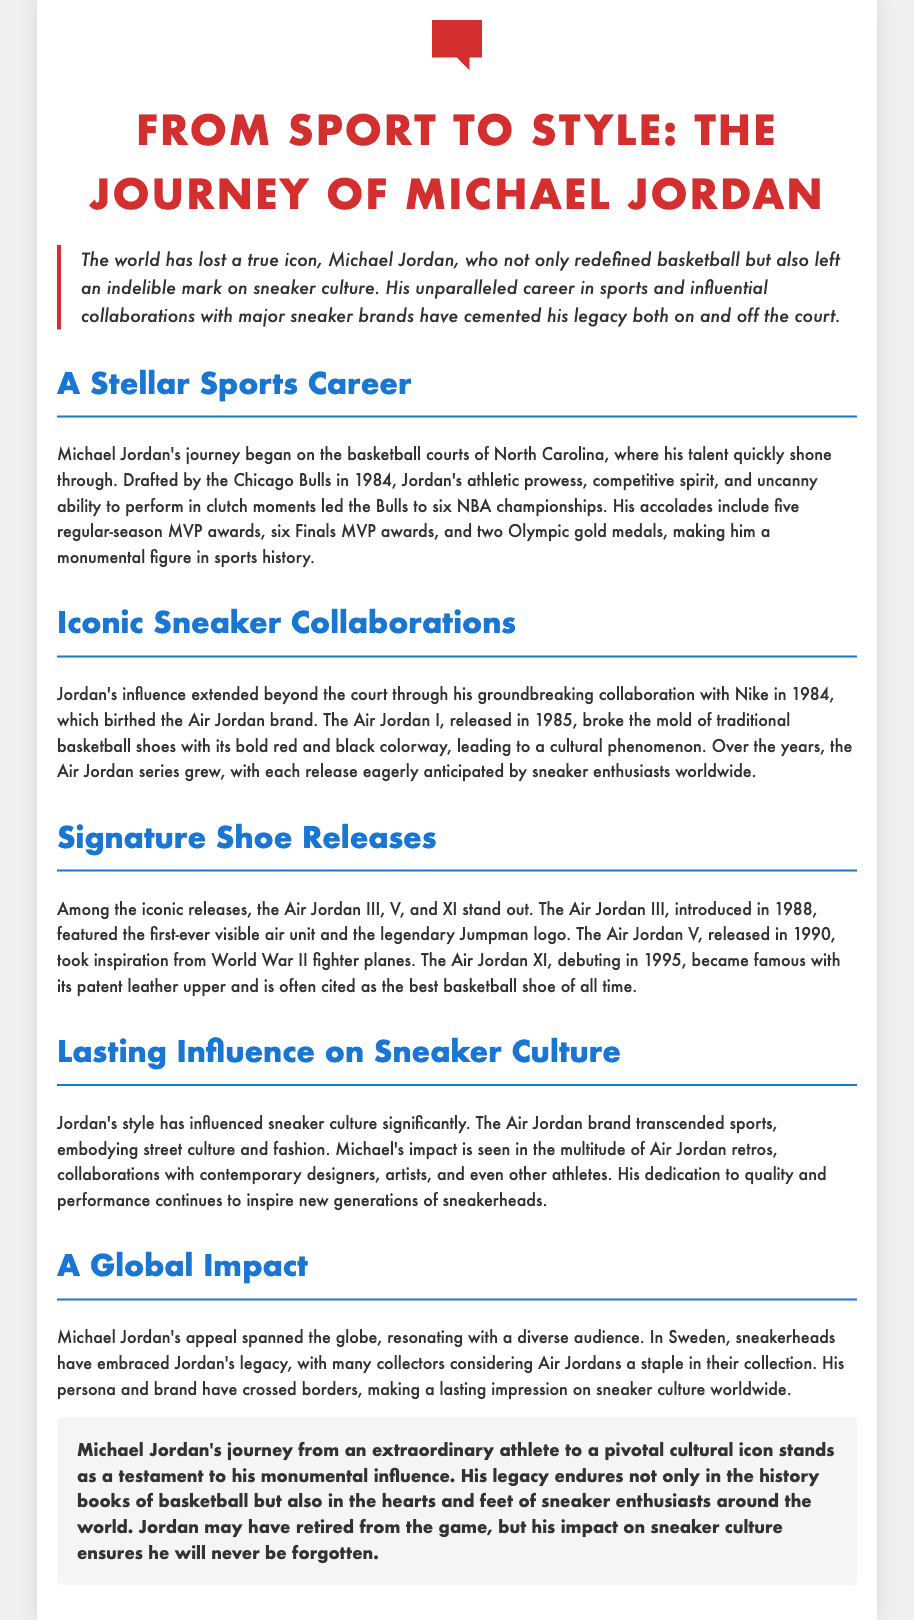What year was Michael Jordan drafted? Michael Jordan was drafted by the Chicago Bulls in 1984, which is mentioned in the document.
Answer: 1984 What is the name of the iconic shoe released in 1985? The Air Jordan I, released in 1985, is highlighted in the document as a groundbreaking shoe.
Answer: Air Jordan I How many NBA championships did Michael Jordan win? The document states that Jordan led the Bulls to six NBA championships.
Answer: Six What was the first Air Jordan model to feature a visible air unit? The Air Jordan III, introduced in 1988, featured the first-ever visible air unit according to the document.
Answer: Air Jordan III Which important sneaker styling feature debuted with the Air Jordan XI? The Air Jordan XI became famous for its patent leather upper, as mentioned in the text.
Answer: Patent leather upper What influence did Michael Jordan have on sneaker culture? The document describes his brand as embodying street culture and fashion, indicating his wide-ranging influence.
Answer: Street culture and fashion Which major brand did Michael Jordan collaborate with in 1984? Michael Jordan's groundbreaking collaboration in 1984 was with Nike, as stated in the document.
Answer: Nike How is Michael Jordan regarded by sneakerheads in Sweden? The document notes that sneakerheads in Sweden have embraced his legacy, indicating his popularity.
Answer: Embraced his legacy What feature is noted about the Air Jordan V? The document points out that the Air Jordan V took inspiration from World War II fighter planes.
Answer: Inspiration from fighter planes 